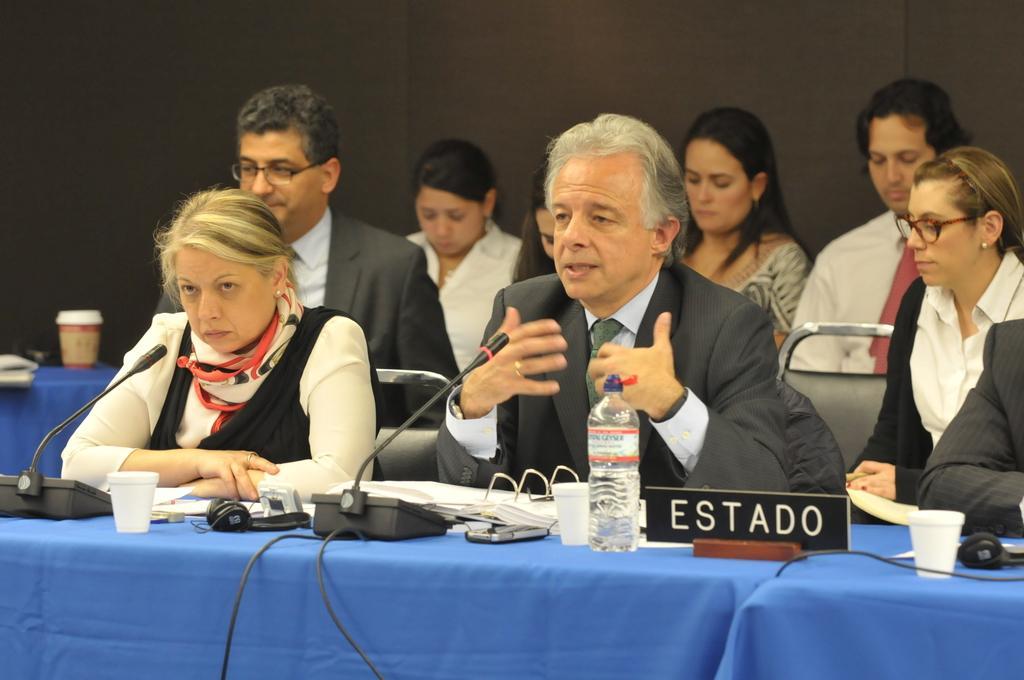In one or two sentences, can you explain what this image depicts? In this image I can see there are few persons siting in front of the table, on the table I can see mike , bottle , glass ,mouse,cable wires kept on it. 